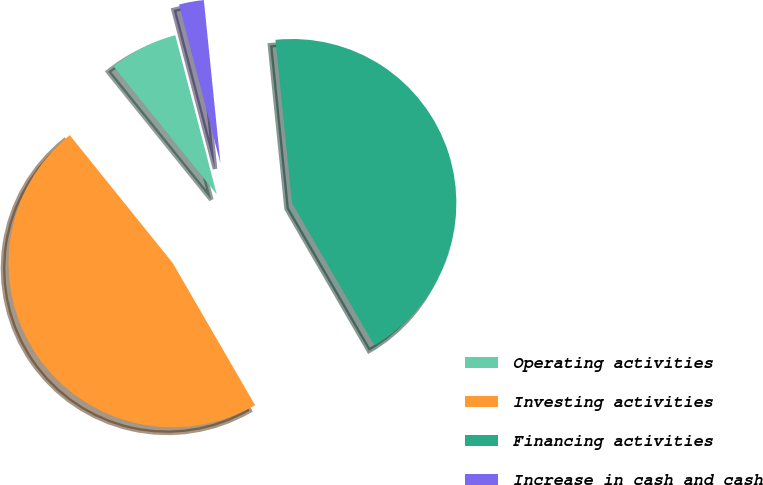Convert chart. <chart><loc_0><loc_0><loc_500><loc_500><pie_chart><fcel>Operating activities<fcel>Investing activities<fcel>Financing activities<fcel>Increase in cash and cash<nl><fcel>6.74%<fcel>47.56%<fcel>43.26%<fcel>2.44%<nl></chart> 